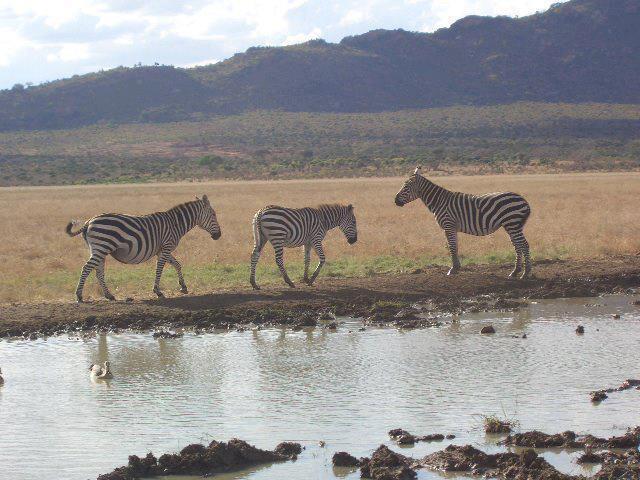How many zebras are next to the water?
Give a very brief answer. 3. How many zebras are there?
Give a very brief answer. 3. How many people are wearing suspenders?
Give a very brief answer. 0. 